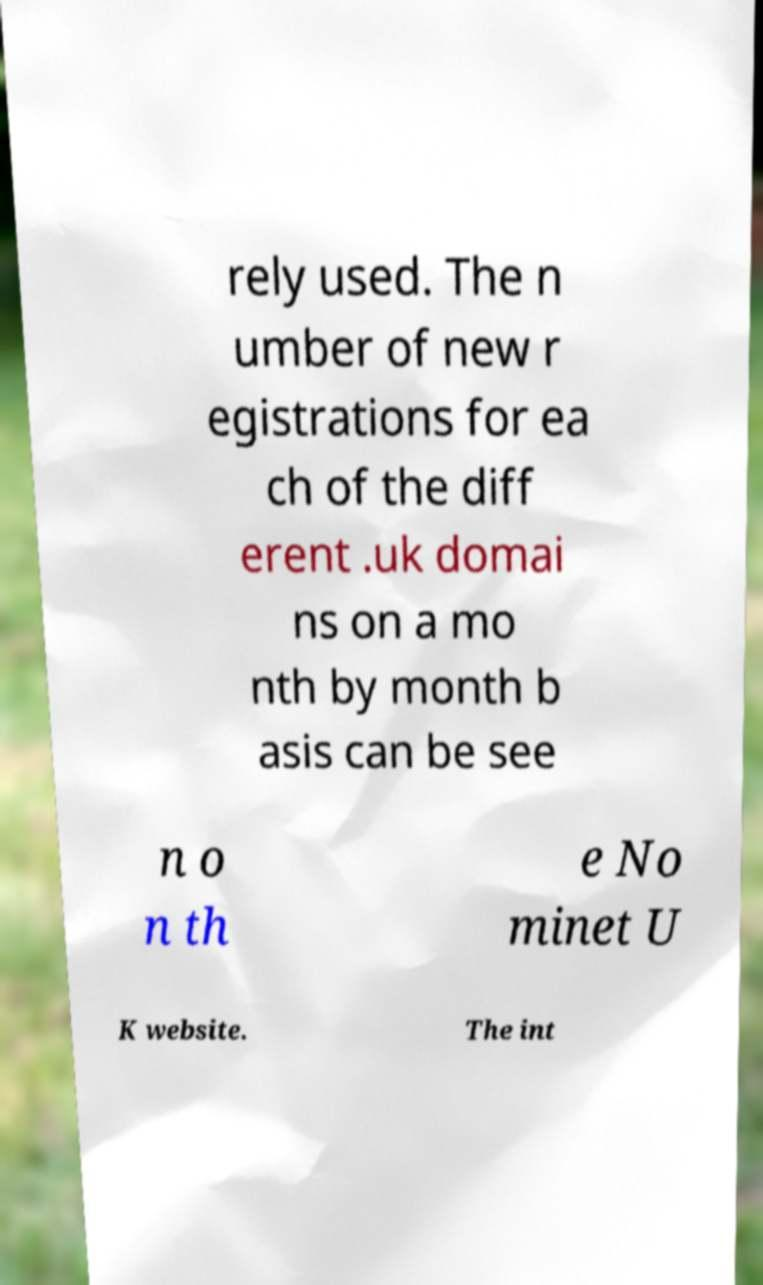Please read and relay the text visible in this image. What does it say? rely used. The n umber of new r egistrations for ea ch of the diff erent .uk domai ns on a mo nth by month b asis can be see n o n th e No minet U K website. The int 